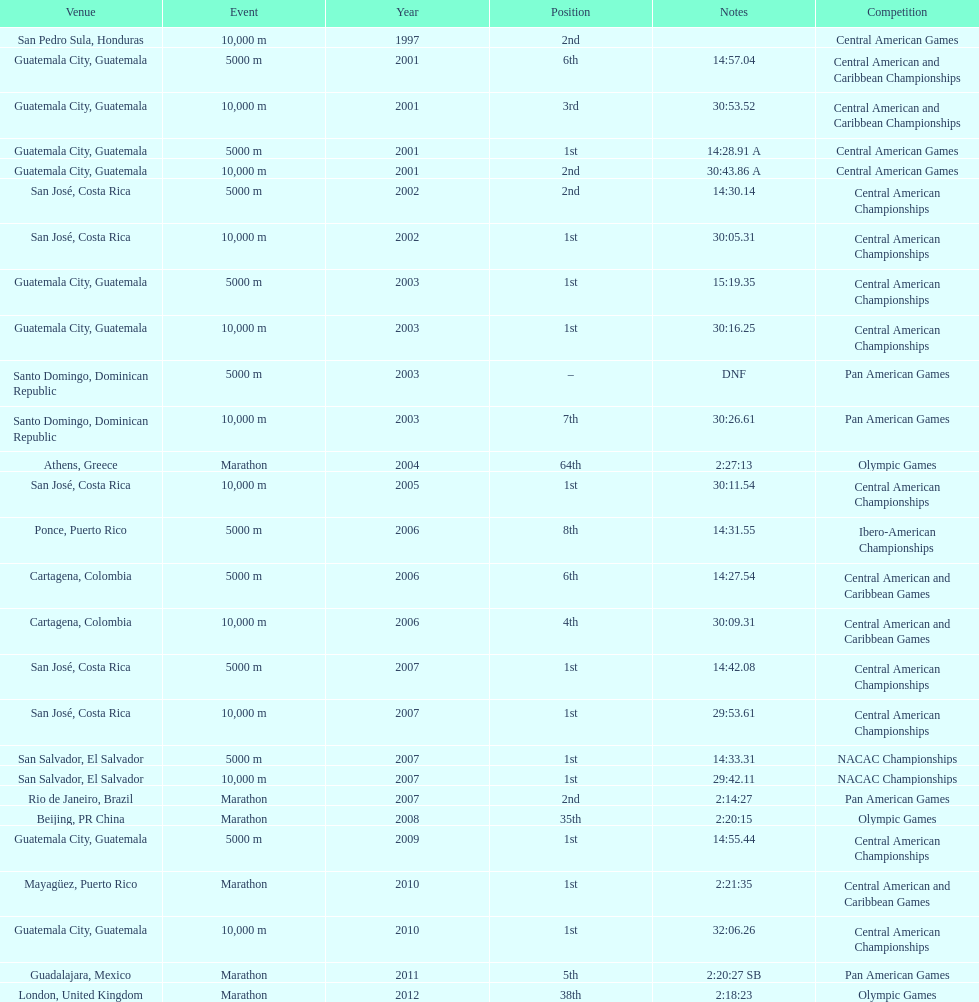Where was the only 64th position held? Athens, Greece. 